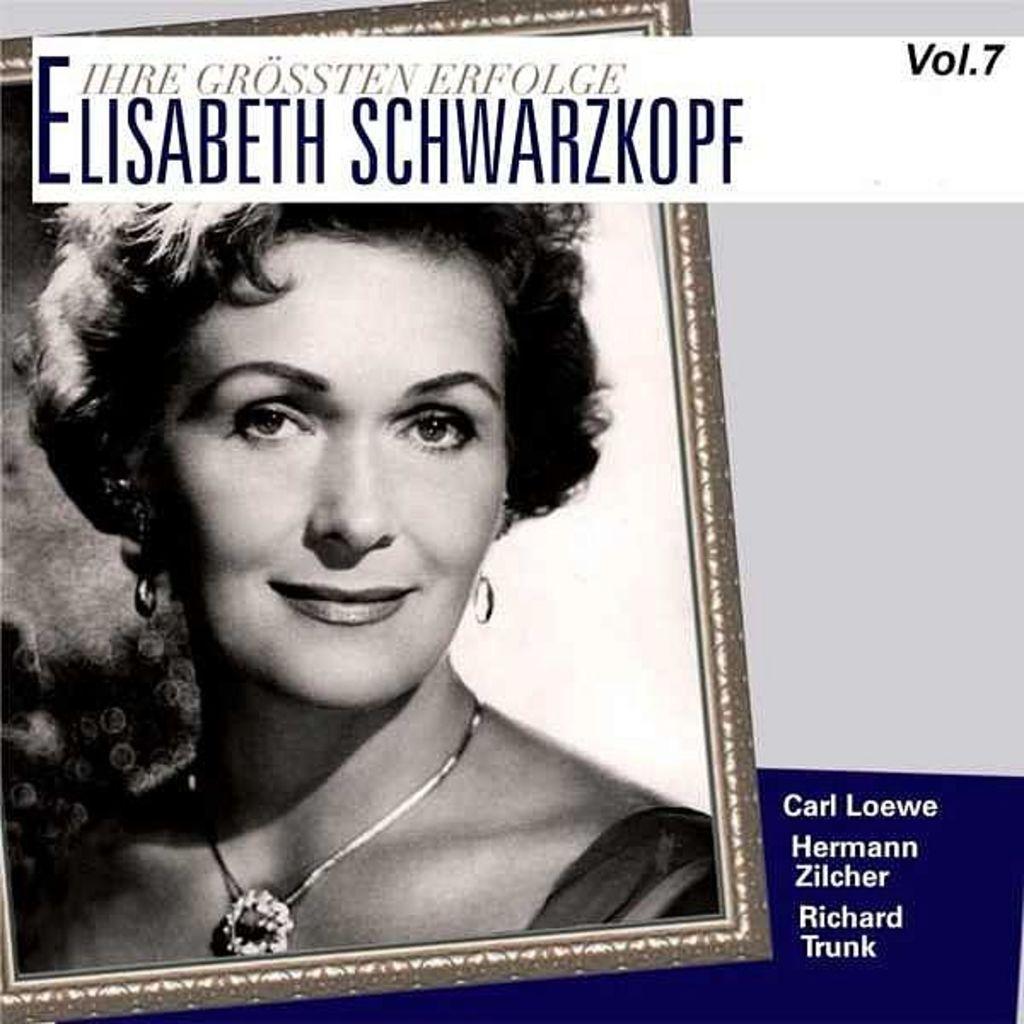Please provide a concise description of this image. In this image we can see a photo frame of a person and on the right of the image we can see some text. 